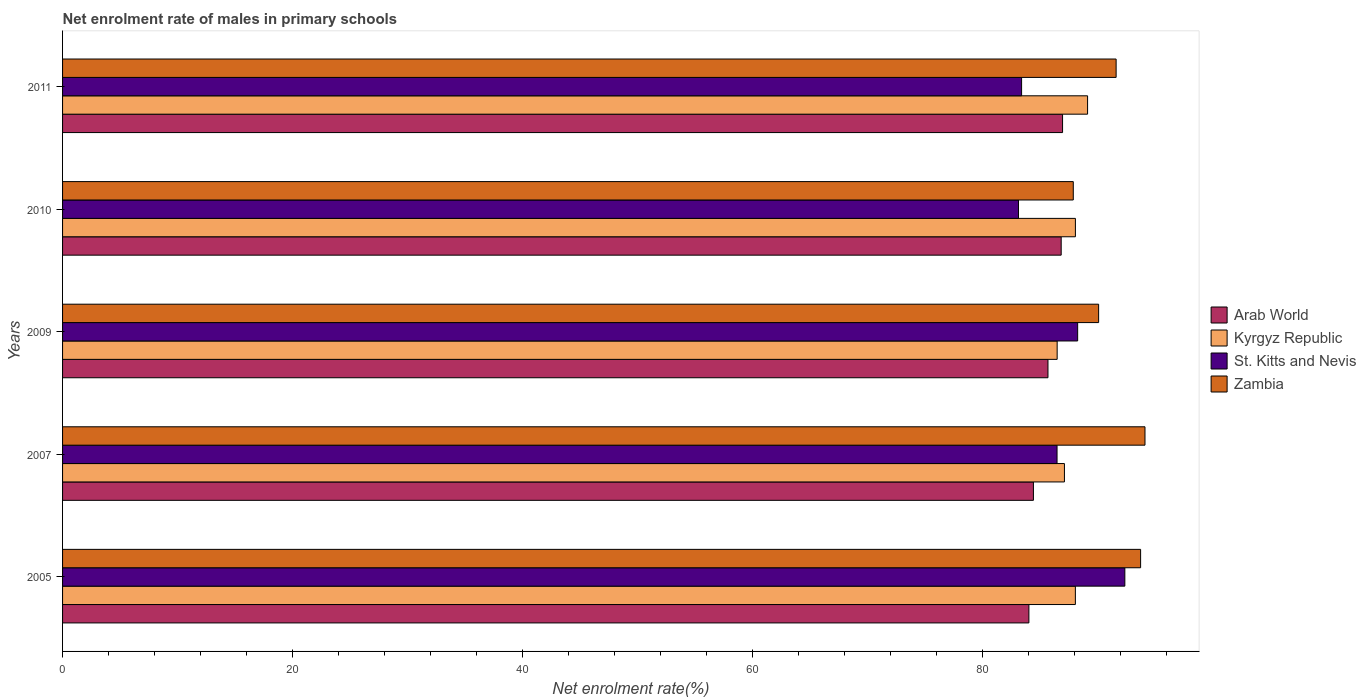How many different coloured bars are there?
Keep it short and to the point. 4. Are the number of bars per tick equal to the number of legend labels?
Your answer should be very brief. Yes. How many bars are there on the 5th tick from the bottom?
Your answer should be compact. 4. In how many cases, is the number of bars for a given year not equal to the number of legend labels?
Offer a terse response. 0. What is the net enrolment rate of males in primary schools in Arab World in 2010?
Give a very brief answer. 86.83. Across all years, what is the maximum net enrolment rate of males in primary schools in Arab World?
Give a very brief answer. 86.95. Across all years, what is the minimum net enrolment rate of males in primary schools in Zambia?
Offer a terse response. 87.88. What is the total net enrolment rate of males in primary schools in St. Kitts and Nevis in the graph?
Make the answer very short. 433.6. What is the difference between the net enrolment rate of males in primary schools in Arab World in 2009 and that in 2010?
Make the answer very short. -1.15. What is the difference between the net enrolment rate of males in primary schools in Zambia in 2010 and the net enrolment rate of males in primary schools in Kyrgyz Republic in 2009?
Your response must be concise. 1.4. What is the average net enrolment rate of males in primary schools in St. Kitts and Nevis per year?
Your answer should be compact. 86.72. In the year 2007, what is the difference between the net enrolment rate of males in primary schools in Zambia and net enrolment rate of males in primary schools in Arab World?
Provide a short and direct response. 9.7. In how many years, is the net enrolment rate of males in primary schools in Kyrgyz Republic greater than 20 %?
Your response must be concise. 5. What is the ratio of the net enrolment rate of males in primary schools in Kyrgyz Republic in 2005 to that in 2011?
Give a very brief answer. 0.99. Is the net enrolment rate of males in primary schools in Kyrgyz Republic in 2010 less than that in 2011?
Offer a terse response. Yes. Is the difference between the net enrolment rate of males in primary schools in Zambia in 2005 and 2011 greater than the difference between the net enrolment rate of males in primary schools in Arab World in 2005 and 2011?
Your answer should be compact. Yes. What is the difference between the highest and the second highest net enrolment rate of males in primary schools in Kyrgyz Republic?
Provide a succinct answer. 1.06. What is the difference between the highest and the lowest net enrolment rate of males in primary schools in Arab World?
Your answer should be compact. 2.93. What does the 2nd bar from the top in 2007 represents?
Make the answer very short. St. Kitts and Nevis. What does the 4th bar from the bottom in 2005 represents?
Make the answer very short. Zambia. Is it the case that in every year, the sum of the net enrolment rate of males in primary schools in St. Kitts and Nevis and net enrolment rate of males in primary schools in Kyrgyz Republic is greater than the net enrolment rate of males in primary schools in Arab World?
Provide a short and direct response. Yes. Are all the bars in the graph horizontal?
Provide a short and direct response. Yes. Are the values on the major ticks of X-axis written in scientific E-notation?
Provide a succinct answer. No. Does the graph contain any zero values?
Provide a short and direct response. No. Where does the legend appear in the graph?
Provide a succinct answer. Center right. How many legend labels are there?
Your response must be concise. 4. How are the legend labels stacked?
Your answer should be very brief. Vertical. What is the title of the graph?
Your answer should be very brief. Net enrolment rate of males in primary schools. Does "High income" appear as one of the legend labels in the graph?
Ensure brevity in your answer.  No. What is the label or title of the X-axis?
Keep it short and to the point. Net enrolment rate(%). What is the label or title of the Y-axis?
Your answer should be compact. Years. What is the Net enrolment rate(%) of Arab World in 2005?
Your response must be concise. 84.02. What is the Net enrolment rate(%) of Kyrgyz Republic in 2005?
Provide a succinct answer. 88.06. What is the Net enrolment rate(%) in St. Kitts and Nevis in 2005?
Offer a terse response. 92.36. What is the Net enrolment rate(%) in Zambia in 2005?
Make the answer very short. 93.74. What is the Net enrolment rate(%) in Arab World in 2007?
Your answer should be very brief. 84.42. What is the Net enrolment rate(%) of Kyrgyz Republic in 2007?
Your answer should be compact. 87.11. What is the Net enrolment rate(%) of St. Kitts and Nevis in 2007?
Provide a short and direct response. 86.47. What is the Net enrolment rate(%) in Zambia in 2007?
Your answer should be compact. 94.12. What is the Net enrolment rate(%) of Arab World in 2009?
Give a very brief answer. 85.68. What is the Net enrolment rate(%) of Kyrgyz Republic in 2009?
Give a very brief answer. 86.48. What is the Net enrolment rate(%) of St. Kitts and Nevis in 2009?
Keep it short and to the point. 88.26. What is the Net enrolment rate(%) in Zambia in 2009?
Provide a succinct answer. 90.09. What is the Net enrolment rate(%) in Arab World in 2010?
Offer a very short reply. 86.83. What is the Net enrolment rate(%) in Kyrgyz Republic in 2010?
Your answer should be very brief. 88.07. What is the Net enrolment rate(%) of St. Kitts and Nevis in 2010?
Offer a terse response. 83.12. What is the Net enrolment rate(%) of Zambia in 2010?
Offer a very short reply. 87.88. What is the Net enrolment rate(%) in Arab World in 2011?
Provide a succinct answer. 86.95. What is the Net enrolment rate(%) in Kyrgyz Republic in 2011?
Provide a succinct answer. 89.12. What is the Net enrolment rate(%) in St. Kitts and Nevis in 2011?
Your answer should be compact. 83.39. What is the Net enrolment rate(%) in Zambia in 2011?
Ensure brevity in your answer.  91.61. Across all years, what is the maximum Net enrolment rate(%) in Arab World?
Keep it short and to the point. 86.95. Across all years, what is the maximum Net enrolment rate(%) of Kyrgyz Republic?
Provide a succinct answer. 89.12. Across all years, what is the maximum Net enrolment rate(%) in St. Kitts and Nevis?
Your answer should be very brief. 92.36. Across all years, what is the maximum Net enrolment rate(%) of Zambia?
Make the answer very short. 94.12. Across all years, what is the minimum Net enrolment rate(%) in Arab World?
Offer a terse response. 84.02. Across all years, what is the minimum Net enrolment rate(%) in Kyrgyz Republic?
Provide a succinct answer. 86.48. Across all years, what is the minimum Net enrolment rate(%) of St. Kitts and Nevis?
Your response must be concise. 83.12. Across all years, what is the minimum Net enrolment rate(%) of Zambia?
Offer a very short reply. 87.88. What is the total Net enrolment rate(%) in Arab World in the graph?
Your answer should be compact. 427.9. What is the total Net enrolment rate(%) in Kyrgyz Republic in the graph?
Give a very brief answer. 438.85. What is the total Net enrolment rate(%) in St. Kitts and Nevis in the graph?
Provide a succinct answer. 433.6. What is the total Net enrolment rate(%) of Zambia in the graph?
Provide a succinct answer. 457.42. What is the difference between the Net enrolment rate(%) in Arab World in 2005 and that in 2007?
Your answer should be compact. -0.39. What is the difference between the Net enrolment rate(%) of Kyrgyz Republic in 2005 and that in 2007?
Your answer should be compact. 0.95. What is the difference between the Net enrolment rate(%) in St. Kitts and Nevis in 2005 and that in 2007?
Your answer should be very brief. 5.89. What is the difference between the Net enrolment rate(%) of Zambia in 2005 and that in 2007?
Ensure brevity in your answer.  -0.38. What is the difference between the Net enrolment rate(%) of Arab World in 2005 and that in 2009?
Give a very brief answer. -1.66. What is the difference between the Net enrolment rate(%) of Kyrgyz Republic in 2005 and that in 2009?
Make the answer very short. 1.58. What is the difference between the Net enrolment rate(%) in St. Kitts and Nevis in 2005 and that in 2009?
Offer a terse response. 4.1. What is the difference between the Net enrolment rate(%) in Zambia in 2005 and that in 2009?
Your answer should be compact. 3.65. What is the difference between the Net enrolment rate(%) of Arab World in 2005 and that in 2010?
Your response must be concise. -2.81. What is the difference between the Net enrolment rate(%) in Kyrgyz Republic in 2005 and that in 2010?
Offer a very short reply. -0. What is the difference between the Net enrolment rate(%) in St. Kitts and Nevis in 2005 and that in 2010?
Make the answer very short. 9.25. What is the difference between the Net enrolment rate(%) of Zambia in 2005 and that in 2010?
Offer a terse response. 5.85. What is the difference between the Net enrolment rate(%) in Arab World in 2005 and that in 2011?
Give a very brief answer. -2.93. What is the difference between the Net enrolment rate(%) in Kyrgyz Republic in 2005 and that in 2011?
Keep it short and to the point. -1.06. What is the difference between the Net enrolment rate(%) of St. Kitts and Nevis in 2005 and that in 2011?
Ensure brevity in your answer.  8.98. What is the difference between the Net enrolment rate(%) of Zambia in 2005 and that in 2011?
Keep it short and to the point. 2.13. What is the difference between the Net enrolment rate(%) of Arab World in 2007 and that in 2009?
Offer a very short reply. -1.26. What is the difference between the Net enrolment rate(%) in Kyrgyz Republic in 2007 and that in 2009?
Provide a succinct answer. 0.63. What is the difference between the Net enrolment rate(%) in St. Kitts and Nevis in 2007 and that in 2009?
Offer a very short reply. -1.79. What is the difference between the Net enrolment rate(%) of Zambia in 2007 and that in 2009?
Ensure brevity in your answer.  4.03. What is the difference between the Net enrolment rate(%) in Arab World in 2007 and that in 2010?
Offer a very short reply. -2.41. What is the difference between the Net enrolment rate(%) in Kyrgyz Republic in 2007 and that in 2010?
Your answer should be compact. -0.95. What is the difference between the Net enrolment rate(%) of St. Kitts and Nevis in 2007 and that in 2010?
Keep it short and to the point. 3.35. What is the difference between the Net enrolment rate(%) of Zambia in 2007 and that in 2010?
Your response must be concise. 6.23. What is the difference between the Net enrolment rate(%) of Arab World in 2007 and that in 2011?
Make the answer very short. -2.53. What is the difference between the Net enrolment rate(%) in Kyrgyz Republic in 2007 and that in 2011?
Offer a very short reply. -2.01. What is the difference between the Net enrolment rate(%) in St. Kitts and Nevis in 2007 and that in 2011?
Offer a terse response. 3.08. What is the difference between the Net enrolment rate(%) of Zambia in 2007 and that in 2011?
Your answer should be compact. 2.51. What is the difference between the Net enrolment rate(%) in Arab World in 2009 and that in 2010?
Your response must be concise. -1.15. What is the difference between the Net enrolment rate(%) of Kyrgyz Republic in 2009 and that in 2010?
Your answer should be compact. -1.59. What is the difference between the Net enrolment rate(%) in St. Kitts and Nevis in 2009 and that in 2010?
Your answer should be compact. 5.14. What is the difference between the Net enrolment rate(%) of Zambia in 2009 and that in 2010?
Keep it short and to the point. 2.2. What is the difference between the Net enrolment rate(%) in Arab World in 2009 and that in 2011?
Make the answer very short. -1.27. What is the difference between the Net enrolment rate(%) of Kyrgyz Republic in 2009 and that in 2011?
Make the answer very short. -2.64. What is the difference between the Net enrolment rate(%) in St. Kitts and Nevis in 2009 and that in 2011?
Offer a terse response. 4.87. What is the difference between the Net enrolment rate(%) in Zambia in 2009 and that in 2011?
Your response must be concise. -1.52. What is the difference between the Net enrolment rate(%) of Arab World in 2010 and that in 2011?
Ensure brevity in your answer.  -0.12. What is the difference between the Net enrolment rate(%) in Kyrgyz Republic in 2010 and that in 2011?
Provide a succinct answer. -1.06. What is the difference between the Net enrolment rate(%) of St. Kitts and Nevis in 2010 and that in 2011?
Provide a succinct answer. -0.27. What is the difference between the Net enrolment rate(%) in Zambia in 2010 and that in 2011?
Keep it short and to the point. -3.73. What is the difference between the Net enrolment rate(%) in Arab World in 2005 and the Net enrolment rate(%) in Kyrgyz Republic in 2007?
Offer a terse response. -3.09. What is the difference between the Net enrolment rate(%) in Arab World in 2005 and the Net enrolment rate(%) in St. Kitts and Nevis in 2007?
Your response must be concise. -2.45. What is the difference between the Net enrolment rate(%) in Arab World in 2005 and the Net enrolment rate(%) in Zambia in 2007?
Offer a terse response. -10.09. What is the difference between the Net enrolment rate(%) of Kyrgyz Republic in 2005 and the Net enrolment rate(%) of St. Kitts and Nevis in 2007?
Give a very brief answer. 1.59. What is the difference between the Net enrolment rate(%) of Kyrgyz Republic in 2005 and the Net enrolment rate(%) of Zambia in 2007?
Your answer should be compact. -6.05. What is the difference between the Net enrolment rate(%) in St. Kitts and Nevis in 2005 and the Net enrolment rate(%) in Zambia in 2007?
Provide a short and direct response. -1.75. What is the difference between the Net enrolment rate(%) of Arab World in 2005 and the Net enrolment rate(%) of Kyrgyz Republic in 2009?
Give a very brief answer. -2.46. What is the difference between the Net enrolment rate(%) of Arab World in 2005 and the Net enrolment rate(%) of St. Kitts and Nevis in 2009?
Provide a short and direct response. -4.24. What is the difference between the Net enrolment rate(%) in Arab World in 2005 and the Net enrolment rate(%) in Zambia in 2009?
Make the answer very short. -6.06. What is the difference between the Net enrolment rate(%) in Kyrgyz Republic in 2005 and the Net enrolment rate(%) in St. Kitts and Nevis in 2009?
Your answer should be very brief. -0.2. What is the difference between the Net enrolment rate(%) of Kyrgyz Republic in 2005 and the Net enrolment rate(%) of Zambia in 2009?
Give a very brief answer. -2.02. What is the difference between the Net enrolment rate(%) in St. Kitts and Nevis in 2005 and the Net enrolment rate(%) in Zambia in 2009?
Provide a short and direct response. 2.28. What is the difference between the Net enrolment rate(%) of Arab World in 2005 and the Net enrolment rate(%) of Kyrgyz Republic in 2010?
Your response must be concise. -4.04. What is the difference between the Net enrolment rate(%) in Arab World in 2005 and the Net enrolment rate(%) in St. Kitts and Nevis in 2010?
Your response must be concise. 0.91. What is the difference between the Net enrolment rate(%) in Arab World in 2005 and the Net enrolment rate(%) in Zambia in 2010?
Your answer should be very brief. -3.86. What is the difference between the Net enrolment rate(%) of Kyrgyz Republic in 2005 and the Net enrolment rate(%) of St. Kitts and Nevis in 2010?
Your answer should be very brief. 4.95. What is the difference between the Net enrolment rate(%) in Kyrgyz Republic in 2005 and the Net enrolment rate(%) in Zambia in 2010?
Your answer should be very brief. 0.18. What is the difference between the Net enrolment rate(%) of St. Kitts and Nevis in 2005 and the Net enrolment rate(%) of Zambia in 2010?
Offer a terse response. 4.48. What is the difference between the Net enrolment rate(%) in Arab World in 2005 and the Net enrolment rate(%) in Kyrgyz Republic in 2011?
Your answer should be compact. -5.1. What is the difference between the Net enrolment rate(%) in Arab World in 2005 and the Net enrolment rate(%) in St. Kitts and Nevis in 2011?
Your response must be concise. 0.63. What is the difference between the Net enrolment rate(%) of Arab World in 2005 and the Net enrolment rate(%) of Zambia in 2011?
Your response must be concise. -7.58. What is the difference between the Net enrolment rate(%) of Kyrgyz Republic in 2005 and the Net enrolment rate(%) of St. Kitts and Nevis in 2011?
Make the answer very short. 4.68. What is the difference between the Net enrolment rate(%) of Kyrgyz Republic in 2005 and the Net enrolment rate(%) of Zambia in 2011?
Make the answer very short. -3.54. What is the difference between the Net enrolment rate(%) of St. Kitts and Nevis in 2005 and the Net enrolment rate(%) of Zambia in 2011?
Keep it short and to the point. 0.76. What is the difference between the Net enrolment rate(%) in Arab World in 2007 and the Net enrolment rate(%) in Kyrgyz Republic in 2009?
Provide a short and direct response. -2.06. What is the difference between the Net enrolment rate(%) in Arab World in 2007 and the Net enrolment rate(%) in St. Kitts and Nevis in 2009?
Provide a succinct answer. -3.85. What is the difference between the Net enrolment rate(%) of Arab World in 2007 and the Net enrolment rate(%) of Zambia in 2009?
Give a very brief answer. -5.67. What is the difference between the Net enrolment rate(%) in Kyrgyz Republic in 2007 and the Net enrolment rate(%) in St. Kitts and Nevis in 2009?
Make the answer very short. -1.15. What is the difference between the Net enrolment rate(%) of Kyrgyz Republic in 2007 and the Net enrolment rate(%) of Zambia in 2009?
Provide a succinct answer. -2.97. What is the difference between the Net enrolment rate(%) in St. Kitts and Nevis in 2007 and the Net enrolment rate(%) in Zambia in 2009?
Your answer should be very brief. -3.62. What is the difference between the Net enrolment rate(%) of Arab World in 2007 and the Net enrolment rate(%) of Kyrgyz Republic in 2010?
Your response must be concise. -3.65. What is the difference between the Net enrolment rate(%) in Arab World in 2007 and the Net enrolment rate(%) in St. Kitts and Nevis in 2010?
Keep it short and to the point. 1.3. What is the difference between the Net enrolment rate(%) of Arab World in 2007 and the Net enrolment rate(%) of Zambia in 2010?
Ensure brevity in your answer.  -3.46. What is the difference between the Net enrolment rate(%) of Kyrgyz Republic in 2007 and the Net enrolment rate(%) of St. Kitts and Nevis in 2010?
Your answer should be very brief. 4. What is the difference between the Net enrolment rate(%) in Kyrgyz Republic in 2007 and the Net enrolment rate(%) in Zambia in 2010?
Give a very brief answer. -0.77. What is the difference between the Net enrolment rate(%) of St. Kitts and Nevis in 2007 and the Net enrolment rate(%) of Zambia in 2010?
Offer a terse response. -1.41. What is the difference between the Net enrolment rate(%) of Arab World in 2007 and the Net enrolment rate(%) of Kyrgyz Republic in 2011?
Offer a terse response. -4.71. What is the difference between the Net enrolment rate(%) of Arab World in 2007 and the Net enrolment rate(%) of St. Kitts and Nevis in 2011?
Offer a very short reply. 1.03. What is the difference between the Net enrolment rate(%) of Arab World in 2007 and the Net enrolment rate(%) of Zambia in 2011?
Make the answer very short. -7.19. What is the difference between the Net enrolment rate(%) of Kyrgyz Republic in 2007 and the Net enrolment rate(%) of St. Kitts and Nevis in 2011?
Ensure brevity in your answer.  3.72. What is the difference between the Net enrolment rate(%) of Kyrgyz Republic in 2007 and the Net enrolment rate(%) of Zambia in 2011?
Make the answer very short. -4.49. What is the difference between the Net enrolment rate(%) of St. Kitts and Nevis in 2007 and the Net enrolment rate(%) of Zambia in 2011?
Keep it short and to the point. -5.14. What is the difference between the Net enrolment rate(%) of Arab World in 2009 and the Net enrolment rate(%) of Kyrgyz Republic in 2010?
Make the answer very short. -2.39. What is the difference between the Net enrolment rate(%) in Arab World in 2009 and the Net enrolment rate(%) in St. Kitts and Nevis in 2010?
Your response must be concise. 2.56. What is the difference between the Net enrolment rate(%) in Arab World in 2009 and the Net enrolment rate(%) in Zambia in 2010?
Your answer should be very brief. -2.2. What is the difference between the Net enrolment rate(%) in Kyrgyz Republic in 2009 and the Net enrolment rate(%) in St. Kitts and Nevis in 2010?
Provide a short and direct response. 3.36. What is the difference between the Net enrolment rate(%) of Kyrgyz Republic in 2009 and the Net enrolment rate(%) of Zambia in 2010?
Your answer should be very brief. -1.4. What is the difference between the Net enrolment rate(%) in St. Kitts and Nevis in 2009 and the Net enrolment rate(%) in Zambia in 2010?
Ensure brevity in your answer.  0.38. What is the difference between the Net enrolment rate(%) of Arab World in 2009 and the Net enrolment rate(%) of Kyrgyz Republic in 2011?
Ensure brevity in your answer.  -3.44. What is the difference between the Net enrolment rate(%) of Arab World in 2009 and the Net enrolment rate(%) of St. Kitts and Nevis in 2011?
Provide a succinct answer. 2.29. What is the difference between the Net enrolment rate(%) in Arab World in 2009 and the Net enrolment rate(%) in Zambia in 2011?
Your answer should be compact. -5.93. What is the difference between the Net enrolment rate(%) in Kyrgyz Republic in 2009 and the Net enrolment rate(%) in St. Kitts and Nevis in 2011?
Offer a terse response. 3.09. What is the difference between the Net enrolment rate(%) of Kyrgyz Republic in 2009 and the Net enrolment rate(%) of Zambia in 2011?
Make the answer very short. -5.13. What is the difference between the Net enrolment rate(%) in St. Kitts and Nevis in 2009 and the Net enrolment rate(%) in Zambia in 2011?
Your response must be concise. -3.35. What is the difference between the Net enrolment rate(%) of Arab World in 2010 and the Net enrolment rate(%) of Kyrgyz Republic in 2011?
Provide a succinct answer. -2.3. What is the difference between the Net enrolment rate(%) in Arab World in 2010 and the Net enrolment rate(%) in St. Kitts and Nevis in 2011?
Offer a terse response. 3.44. What is the difference between the Net enrolment rate(%) of Arab World in 2010 and the Net enrolment rate(%) of Zambia in 2011?
Keep it short and to the point. -4.78. What is the difference between the Net enrolment rate(%) in Kyrgyz Republic in 2010 and the Net enrolment rate(%) in St. Kitts and Nevis in 2011?
Offer a very short reply. 4.68. What is the difference between the Net enrolment rate(%) of Kyrgyz Republic in 2010 and the Net enrolment rate(%) of Zambia in 2011?
Your answer should be compact. -3.54. What is the difference between the Net enrolment rate(%) of St. Kitts and Nevis in 2010 and the Net enrolment rate(%) of Zambia in 2011?
Give a very brief answer. -8.49. What is the average Net enrolment rate(%) in Arab World per year?
Offer a very short reply. 85.58. What is the average Net enrolment rate(%) in Kyrgyz Republic per year?
Make the answer very short. 87.77. What is the average Net enrolment rate(%) in St. Kitts and Nevis per year?
Your answer should be compact. 86.72. What is the average Net enrolment rate(%) of Zambia per year?
Provide a short and direct response. 91.48. In the year 2005, what is the difference between the Net enrolment rate(%) in Arab World and Net enrolment rate(%) in Kyrgyz Republic?
Your answer should be compact. -4.04. In the year 2005, what is the difference between the Net enrolment rate(%) of Arab World and Net enrolment rate(%) of St. Kitts and Nevis?
Offer a terse response. -8.34. In the year 2005, what is the difference between the Net enrolment rate(%) of Arab World and Net enrolment rate(%) of Zambia?
Offer a very short reply. -9.71. In the year 2005, what is the difference between the Net enrolment rate(%) of Kyrgyz Republic and Net enrolment rate(%) of St. Kitts and Nevis?
Your answer should be very brief. -4.3. In the year 2005, what is the difference between the Net enrolment rate(%) of Kyrgyz Republic and Net enrolment rate(%) of Zambia?
Provide a short and direct response. -5.67. In the year 2005, what is the difference between the Net enrolment rate(%) of St. Kitts and Nevis and Net enrolment rate(%) of Zambia?
Provide a succinct answer. -1.37. In the year 2007, what is the difference between the Net enrolment rate(%) of Arab World and Net enrolment rate(%) of Kyrgyz Republic?
Keep it short and to the point. -2.7. In the year 2007, what is the difference between the Net enrolment rate(%) of Arab World and Net enrolment rate(%) of St. Kitts and Nevis?
Your response must be concise. -2.05. In the year 2007, what is the difference between the Net enrolment rate(%) in Arab World and Net enrolment rate(%) in Zambia?
Keep it short and to the point. -9.7. In the year 2007, what is the difference between the Net enrolment rate(%) in Kyrgyz Republic and Net enrolment rate(%) in St. Kitts and Nevis?
Provide a short and direct response. 0.64. In the year 2007, what is the difference between the Net enrolment rate(%) of Kyrgyz Republic and Net enrolment rate(%) of Zambia?
Make the answer very short. -7. In the year 2007, what is the difference between the Net enrolment rate(%) in St. Kitts and Nevis and Net enrolment rate(%) in Zambia?
Keep it short and to the point. -7.65. In the year 2009, what is the difference between the Net enrolment rate(%) of Arab World and Net enrolment rate(%) of Kyrgyz Republic?
Your response must be concise. -0.8. In the year 2009, what is the difference between the Net enrolment rate(%) in Arab World and Net enrolment rate(%) in St. Kitts and Nevis?
Offer a very short reply. -2.58. In the year 2009, what is the difference between the Net enrolment rate(%) of Arab World and Net enrolment rate(%) of Zambia?
Provide a succinct answer. -4.4. In the year 2009, what is the difference between the Net enrolment rate(%) in Kyrgyz Republic and Net enrolment rate(%) in St. Kitts and Nevis?
Give a very brief answer. -1.78. In the year 2009, what is the difference between the Net enrolment rate(%) of Kyrgyz Republic and Net enrolment rate(%) of Zambia?
Ensure brevity in your answer.  -3.61. In the year 2009, what is the difference between the Net enrolment rate(%) of St. Kitts and Nevis and Net enrolment rate(%) of Zambia?
Offer a terse response. -1.82. In the year 2010, what is the difference between the Net enrolment rate(%) of Arab World and Net enrolment rate(%) of Kyrgyz Republic?
Give a very brief answer. -1.24. In the year 2010, what is the difference between the Net enrolment rate(%) of Arab World and Net enrolment rate(%) of St. Kitts and Nevis?
Provide a short and direct response. 3.71. In the year 2010, what is the difference between the Net enrolment rate(%) of Arab World and Net enrolment rate(%) of Zambia?
Make the answer very short. -1.05. In the year 2010, what is the difference between the Net enrolment rate(%) in Kyrgyz Republic and Net enrolment rate(%) in St. Kitts and Nevis?
Provide a short and direct response. 4.95. In the year 2010, what is the difference between the Net enrolment rate(%) in Kyrgyz Republic and Net enrolment rate(%) in Zambia?
Your answer should be compact. 0.19. In the year 2010, what is the difference between the Net enrolment rate(%) of St. Kitts and Nevis and Net enrolment rate(%) of Zambia?
Keep it short and to the point. -4.76. In the year 2011, what is the difference between the Net enrolment rate(%) of Arab World and Net enrolment rate(%) of Kyrgyz Republic?
Give a very brief answer. -2.17. In the year 2011, what is the difference between the Net enrolment rate(%) in Arab World and Net enrolment rate(%) in St. Kitts and Nevis?
Your answer should be very brief. 3.56. In the year 2011, what is the difference between the Net enrolment rate(%) in Arab World and Net enrolment rate(%) in Zambia?
Provide a short and direct response. -4.66. In the year 2011, what is the difference between the Net enrolment rate(%) in Kyrgyz Republic and Net enrolment rate(%) in St. Kitts and Nevis?
Ensure brevity in your answer.  5.74. In the year 2011, what is the difference between the Net enrolment rate(%) of Kyrgyz Republic and Net enrolment rate(%) of Zambia?
Keep it short and to the point. -2.48. In the year 2011, what is the difference between the Net enrolment rate(%) in St. Kitts and Nevis and Net enrolment rate(%) in Zambia?
Your answer should be very brief. -8.22. What is the ratio of the Net enrolment rate(%) in Kyrgyz Republic in 2005 to that in 2007?
Offer a terse response. 1.01. What is the ratio of the Net enrolment rate(%) of St. Kitts and Nevis in 2005 to that in 2007?
Provide a succinct answer. 1.07. What is the ratio of the Net enrolment rate(%) of Zambia in 2005 to that in 2007?
Provide a succinct answer. 1. What is the ratio of the Net enrolment rate(%) in Arab World in 2005 to that in 2009?
Provide a succinct answer. 0.98. What is the ratio of the Net enrolment rate(%) of Kyrgyz Republic in 2005 to that in 2009?
Give a very brief answer. 1.02. What is the ratio of the Net enrolment rate(%) in St. Kitts and Nevis in 2005 to that in 2009?
Give a very brief answer. 1.05. What is the ratio of the Net enrolment rate(%) in Zambia in 2005 to that in 2009?
Offer a very short reply. 1.04. What is the ratio of the Net enrolment rate(%) in Kyrgyz Republic in 2005 to that in 2010?
Offer a very short reply. 1. What is the ratio of the Net enrolment rate(%) of St. Kitts and Nevis in 2005 to that in 2010?
Your response must be concise. 1.11. What is the ratio of the Net enrolment rate(%) of Zambia in 2005 to that in 2010?
Provide a succinct answer. 1.07. What is the ratio of the Net enrolment rate(%) in Arab World in 2005 to that in 2011?
Offer a terse response. 0.97. What is the ratio of the Net enrolment rate(%) in St. Kitts and Nevis in 2005 to that in 2011?
Make the answer very short. 1.11. What is the ratio of the Net enrolment rate(%) in Zambia in 2005 to that in 2011?
Your answer should be compact. 1.02. What is the ratio of the Net enrolment rate(%) of Arab World in 2007 to that in 2009?
Your answer should be compact. 0.99. What is the ratio of the Net enrolment rate(%) of Kyrgyz Republic in 2007 to that in 2009?
Your answer should be very brief. 1.01. What is the ratio of the Net enrolment rate(%) of St. Kitts and Nevis in 2007 to that in 2009?
Provide a short and direct response. 0.98. What is the ratio of the Net enrolment rate(%) of Zambia in 2007 to that in 2009?
Offer a terse response. 1.04. What is the ratio of the Net enrolment rate(%) in Arab World in 2007 to that in 2010?
Offer a terse response. 0.97. What is the ratio of the Net enrolment rate(%) of Kyrgyz Republic in 2007 to that in 2010?
Offer a terse response. 0.99. What is the ratio of the Net enrolment rate(%) in St. Kitts and Nevis in 2007 to that in 2010?
Your answer should be very brief. 1.04. What is the ratio of the Net enrolment rate(%) of Zambia in 2007 to that in 2010?
Your answer should be compact. 1.07. What is the ratio of the Net enrolment rate(%) of Arab World in 2007 to that in 2011?
Offer a very short reply. 0.97. What is the ratio of the Net enrolment rate(%) of Kyrgyz Republic in 2007 to that in 2011?
Your response must be concise. 0.98. What is the ratio of the Net enrolment rate(%) in Zambia in 2007 to that in 2011?
Give a very brief answer. 1.03. What is the ratio of the Net enrolment rate(%) in Arab World in 2009 to that in 2010?
Offer a very short reply. 0.99. What is the ratio of the Net enrolment rate(%) in Kyrgyz Republic in 2009 to that in 2010?
Ensure brevity in your answer.  0.98. What is the ratio of the Net enrolment rate(%) in St. Kitts and Nevis in 2009 to that in 2010?
Provide a succinct answer. 1.06. What is the ratio of the Net enrolment rate(%) in Zambia in 2009 to that in 2010?
Provide a short and direct response. 1.03. What is the ratio of the Net enrolment rate(%) in Arab World in 2009 to that in 2011?
Offer a very short reply. 0.99. What is the ratio of the Net enrolment rate(%) of Kyrgyz Republic in 2009 to that in 2011?
Your response must be concise. 0.97. What is the ratio of the Net enrolment rate(%) of St. Kitts and Nevis in 2009 to that in 2011?
Offer a very short reply. 1.06. What is the ratio of the Net enrolment rate(%) of Zambia in 2009 to that in 2011?
Provide a short and direct response. 0.98. What is the ratio of the Net enrolment rate(%) of Zambia in 2010 to that in 2011?
Keep it short and to the point. 0.96. What is the difference between the highest and the second highest Net enrolment rate(%) of Arab World?
Your answer should be compact. 0.12. What is the difference between the highest and the second highest Net enrolment rate(%) of Kyrgyz Republic?
Your response must be concise. 1.06. What is the difference between the highest and the second highest Net enrolment rate(%) of St. Kitts and Nevis?
Keep it short and to the point. 4.1. What is the difference between the highest and the second highest Net enrolment rate(%) of Zambia?
Provide a succinct answer. 0.38. What is the difference between the highest and the lowest Net enrolment rate(%) of Arab World?
Provide a short and direct response. 2.93. What is the difference between the highest and the lowest Net enrolment rate(%) in Kyrgyz Republic?
Offer a very short reply. 2.64. What is the difference between the highest and the lowest Net enrolment rate(%) in St. Kitts and Nevis?
Make the answer very short. 9.25. What is the difference between the highest and the lowest Net enrolment rate(%) in Zambia?
Your answer should be compact. 6.23. 